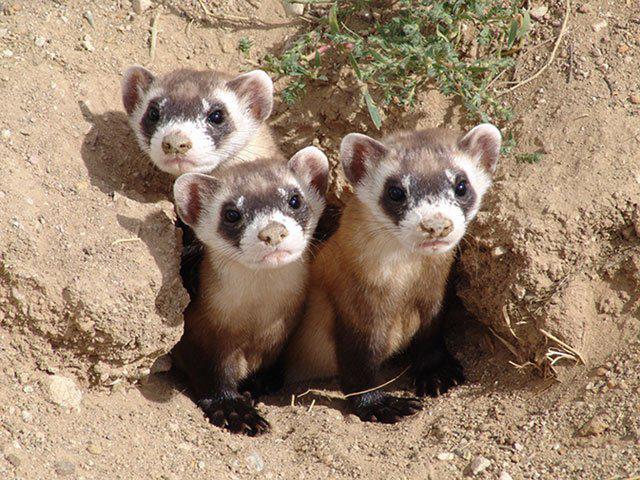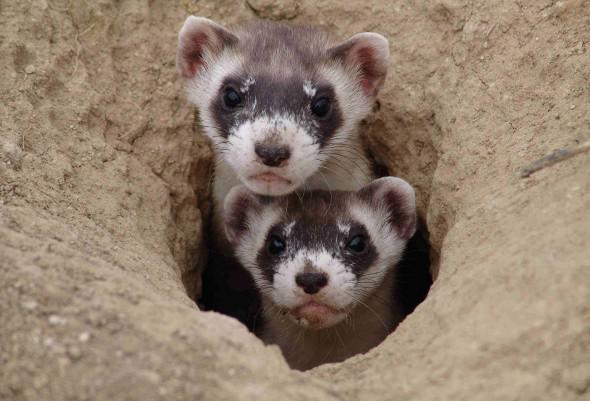The first image is the image on the left, the second image is the image on the right. Evaluate the accuracy of this statement regarding the images: "There is at least one ferret in a hole.". Is it true? Answer yes or no. Yes. The first image is the image on the left, the second image is the image on the right. For the images shown, is this caption "The left and right image contains the same number of small rodents." true? Answer yes or no. No. 